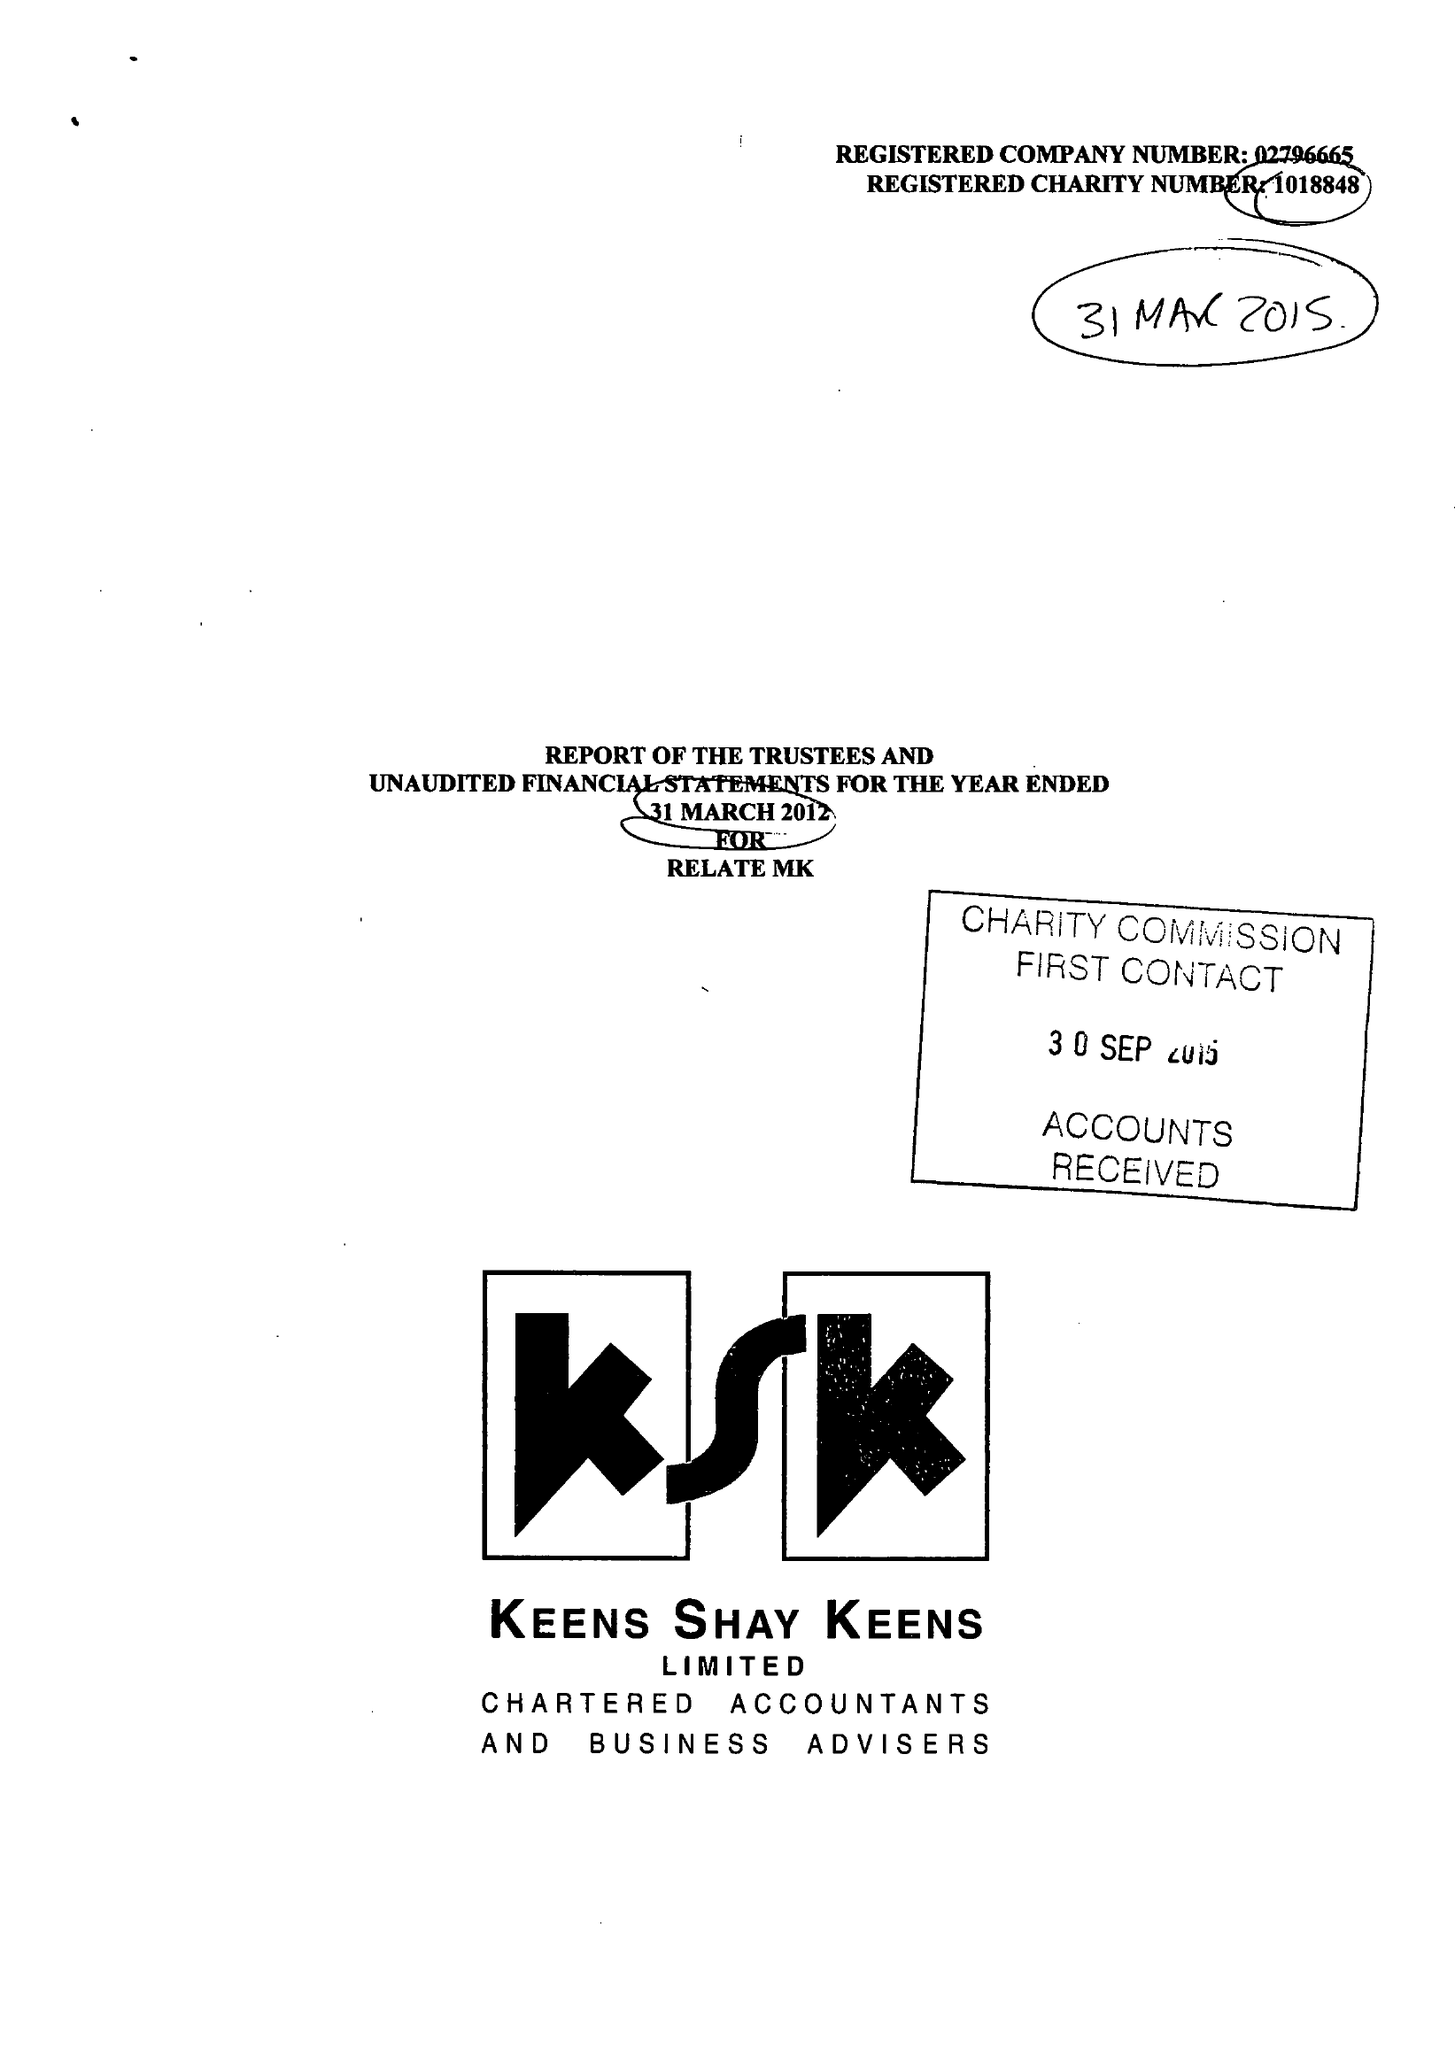What is the value for the report_date?
Answer the question using a single word or phrase. 2015-03-31 